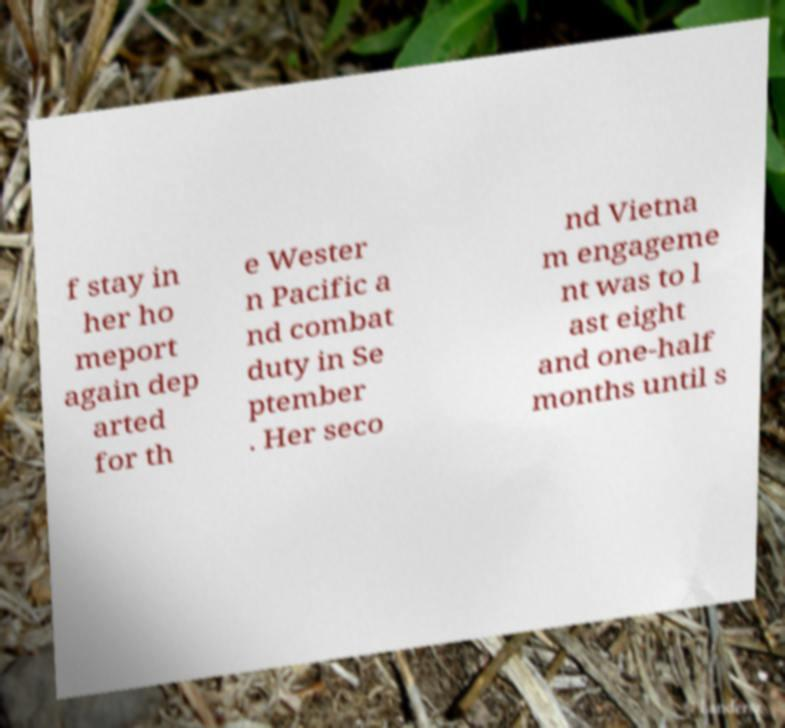For documentation purposes, I need the text within this image transcribed. Could you provide that? f stay in her ho meport again dep arted for th e Wester n Pacific a nd combat duty in Se ptember . Her seco nd Vietna m engageme nt was to l ast eight and one-half months until s 